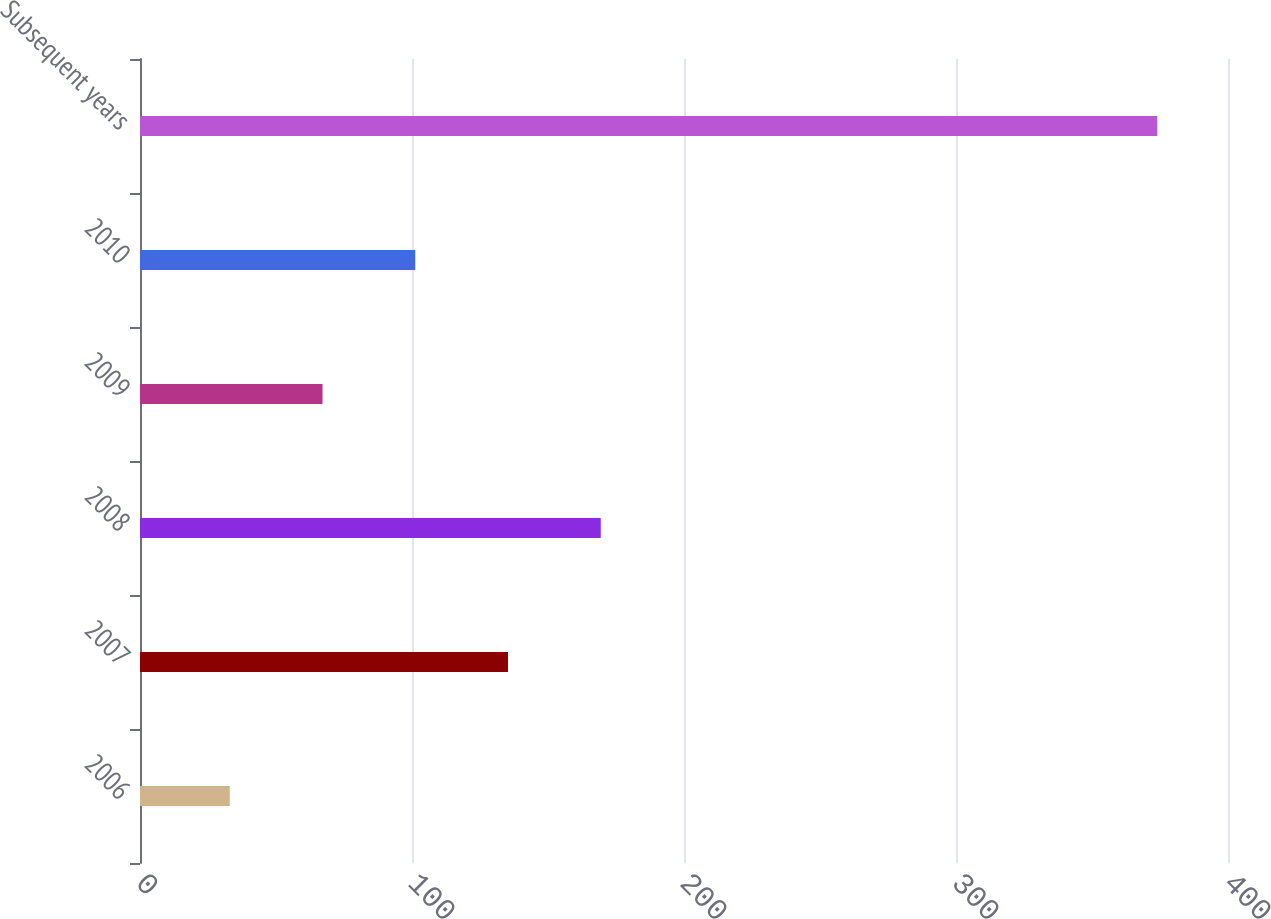Convert chart to OTSL. <chart><loc_0><loc_0><loc_500><loc_500><bar_chart><fcel>2006<fcel>2007<fcel>2008<fcel>2009<fcel>2010<fcel>Subsequent years<nl><fcel>33<fcel>135.3<fcel>169.4<fcel>67.1<fcel>101.2<fcel>374<nl></chart> 